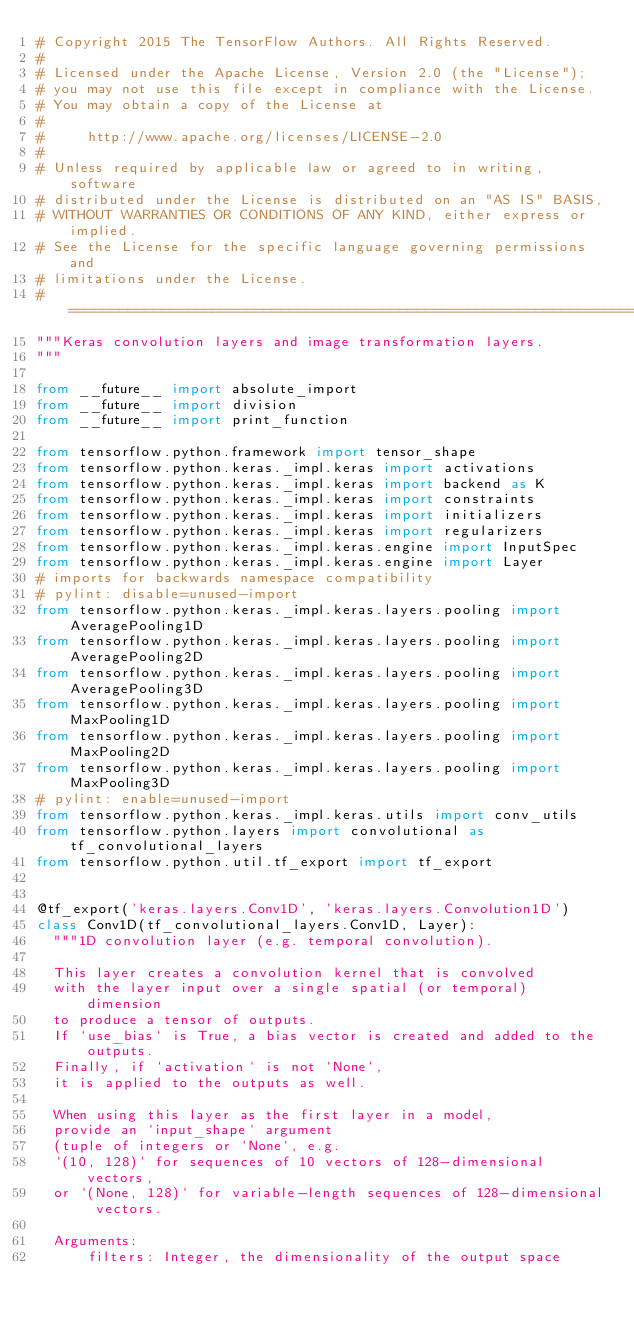<code> <loc_0><loc_0><loc_500><loc_500><_Python_># Copyright 2015 The TensorFlow Authors. All Rights Reserved.
#
# Licensed under the Apache License, Version 2.0 (the "License");
# you may not use this file except in compliance with the License.
# You may obtain a copy of the License at
#
#     http://www.apache.org/licenses/LICENSE-2.0
#
# Unless required by applicable law or agreed to in writing, software
# distributed under the License is distributed on an "AS IS" BASIS,
# WITHOUT WARRANTIES OR CONDITIONS OF ANY KIND, either express or implied.
# See the License for the specific language governing permissions and
# limitations under the License.
# ==============================================================================
"""Keras convolution layers and image transformation layers.
"""

from __future__ import absolute_import
from __future__ import division
from __future__ import print_function

from tensorflow.python.framework import tensor_shape
from tensorflow.python.keras._impl.keras import activations
from tensorflow.python.keras._impl.keras import backend as K
from tensorflow.python.keras._impl.keras import constraints
from tensorflow.python.keras._impl.keras import initializers
from tensorflow.python.keras._impl.keras import regularizers
from tensorflow.python.keras._impl.keras.engine import InputSpec
from tensorflow.python.keras._impl.keras.engine import Layer
# imports for backwards namespace compatibility
# pylint: disable=unused-import
from tensorflow.python.keras._impl.keras.layers.pooling import AveragePooling1D
from tensorflow.python.keras._impl.keras.layers.pooling import AveragePooling2D
from tensorflow.python.keras._impl.keras.layers.pooling import AveragePooling3D
from tensorflow.python.keras._impl.keras.layers.pooling import MaxPooling1D
from tensorflow.python.keras._impl.keras.layers.pooling import MaxPooling2D
from tensorflow.python.keras._impl.keras.layers.pooling import MaxPooling3D
# pylint: enable=unused-import
from tensorflow.python.keras._impl.keras.utils import conv_utils
from tensorflow.python.layers import convolutional as tf_convolutional_layers
from tensorflow.python.util.tf_export import tf_export


@tf_export('keras.layers.Conv1D', 'keras.layers.Convolution1D')
class Conv1D(tf_convolutional_layers.Conv1D, Layer):
  """1D convolution layer (e.g. temporal convolution).

  This layer creates a convolution kernel that is convolved
  with the layer input over a single spatial (or temporal) dimension
  to produce a tensor of outputs.
  If `use_bias` is True, a bias vector is created and added to the outputs.
  Finally, if `activation` is not `None`,
  it is applied to the outputs as well.

  When using this layer as the first layer in a model,
  provide an `input_shape` argument
  (tuple of integers or `None`, e.g.
  `(10, 128)` for sequences of 10 vectors of 128-dimensional vectors,
  or `(None, 128)` for variable-length sequences of 128-dimensional vectors.

  Arguments:
      filters: Integer, the dimensionality of the output space</code> 